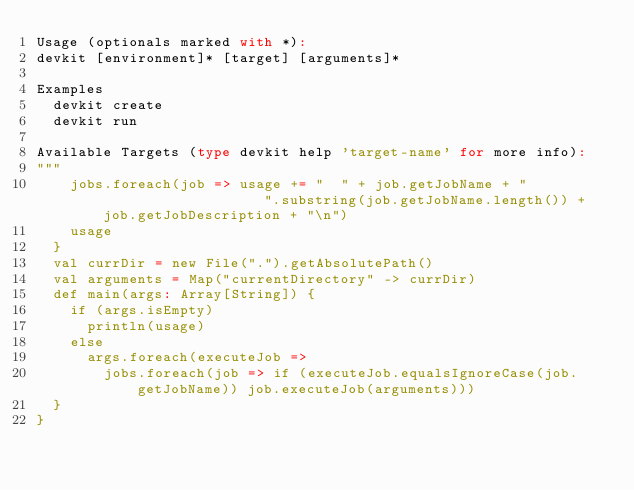<code> <loc_0><loc_0><loc_500><loc_500><_Scala_>Usage (optionals marked with *): 
devkit [environment]* [target] [arguments]*
   
Examples
  devkit create
  devkit run
    
Available Targets (type devkit help 'target-name' for more info):
"""
    jobs.foreach(job => usage += "  " + job.getJobName + "                    ".substring(job.getJobName.length()) + job.getJobDescription + "\n")
    usage
  }
  val currDir = new File(".").getAbsolutePath()
  val arguments = Map("currentDirectory" -> currDir)
  def main(args: Array[String]) {
    if (args.isEmpty)
      println(usage)
    else
      args.foreach(executeJob =>
        jobs.foreach(job => if (executeJob.equalsIgnoreCase(job.getJobName)) job.executeJob(arguments)))
  }
}
</code> 